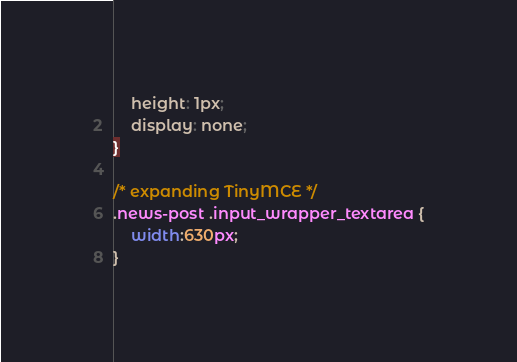<code> <loc_0><loc_0><loc_500><loc_500><_CSS_>    height: 1px;
    display: none;
}

/* expanding TinyMCE */
.news-post .input_wrapper_textarea {
    width:630px;
}</code> 